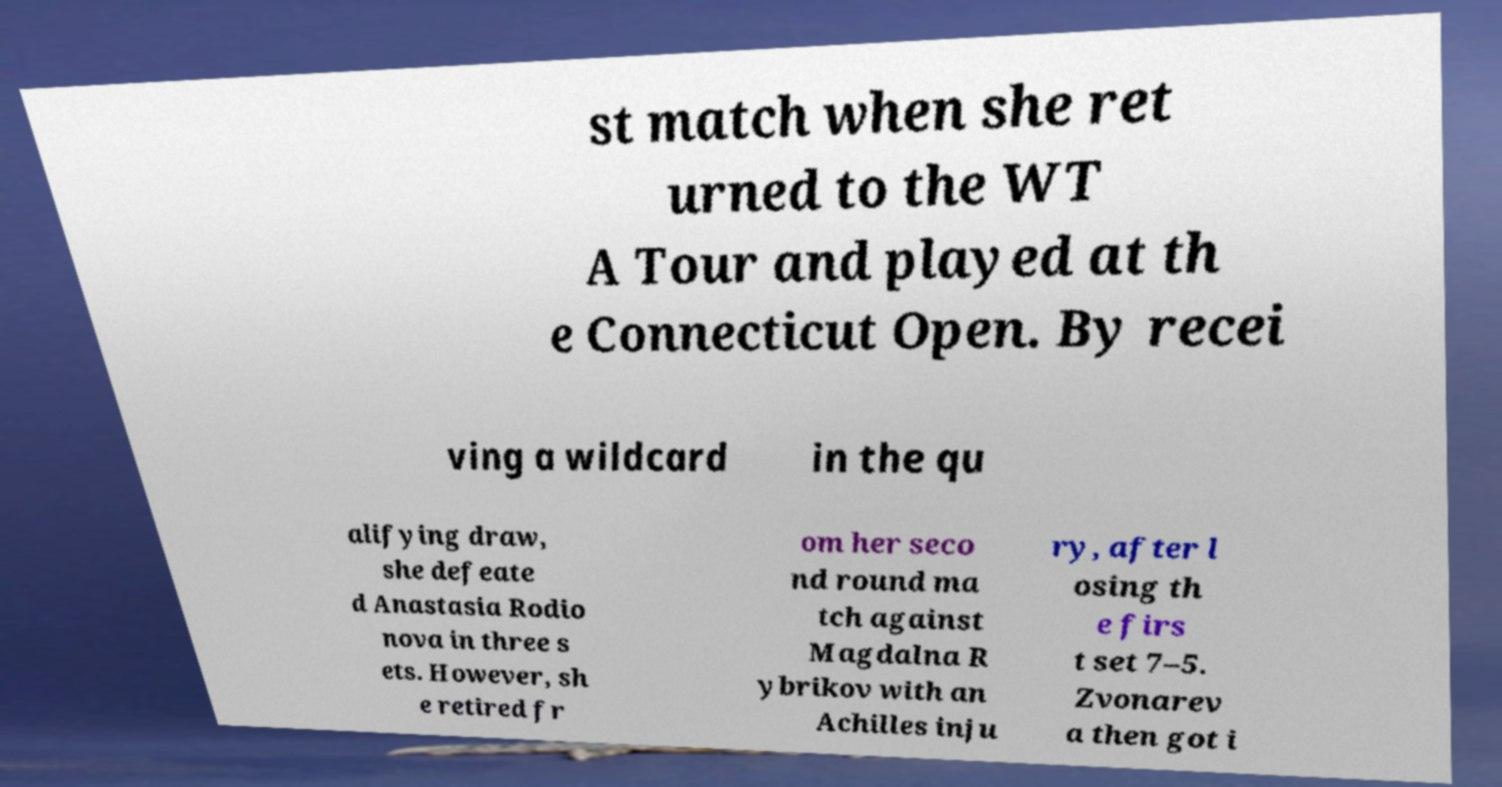There's text embedded in this image that I need extracted. Can you transcribe it verbatim? st match when she ret urned to the WT A Tour and played at th e Connecticut Open. By recei ving a wildcard in the qu alifying draw, she defeate d Anastasia Rodio nova in three s ets. However, sh e retired fr om her seco nd round ma tch against Magdalna R ybrikov with an Achilles inju ry, after l osing th e firs t set 7–5. Zvonarev a then got i 